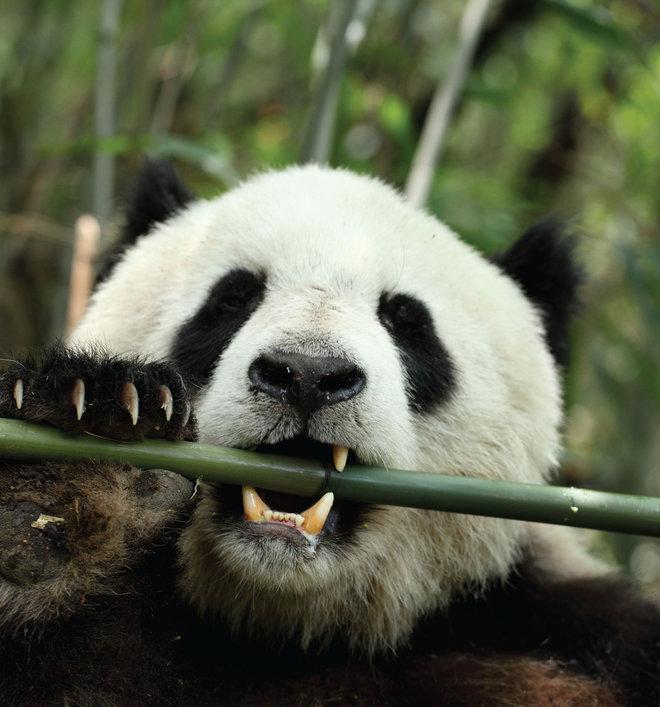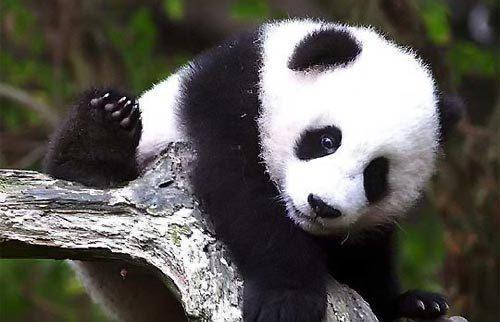The first image is the image on the left, the second image is the image on the right. Analyze the images presented: Is the assertion "In a tree is a panda not eating bamboo" valid? Answer yes or no. Yes. The first image is the image on the left, the second image is the image on the right. For the images displayed, is the sentence "There are three pandas" factually correct? Answer yes or no. No. 